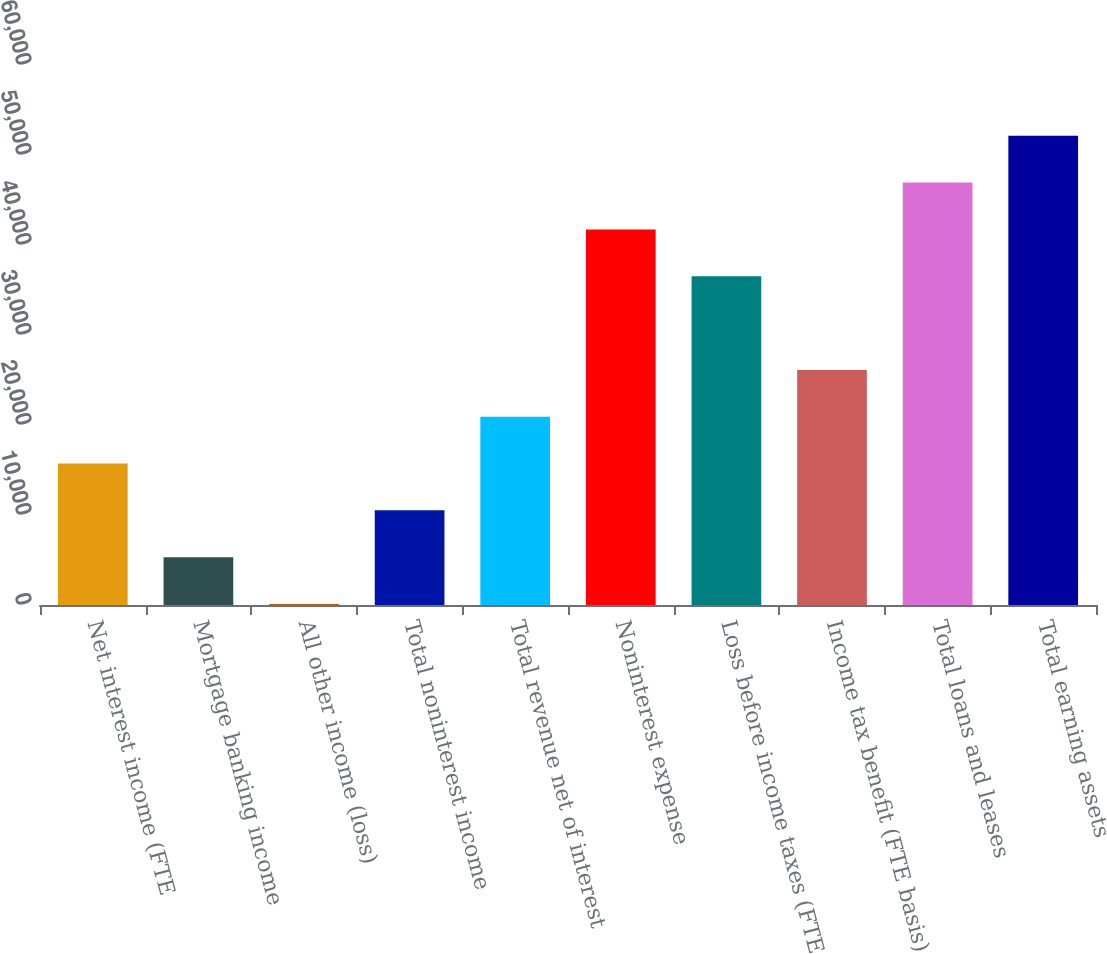Convert chart to OTSL. <chart><loc_0><loc_0><loc_500><loc_500><bar_chart><fcel>Net interest income (FTE<fcel>Mortgage banking income<fcel>All other income (loss)<fcel>Total noninterest income<fcel>Total revenue net of interest<fcel>Noninterest expense<fcel>Loss before income taxes (FTE<fcel>Income tax benefit (FTE basis)<fcel>Total loans and leases<fcel>Total earning assets<nl><fcel>15717.9<fcel>5313.3<fcel>111<fcel>10515.6<fcel>20920.2<fcel>41729.4<fcel>36527.1<fcel>26122.5<fcel>46931.7<fcel>52134<nl></chart> 